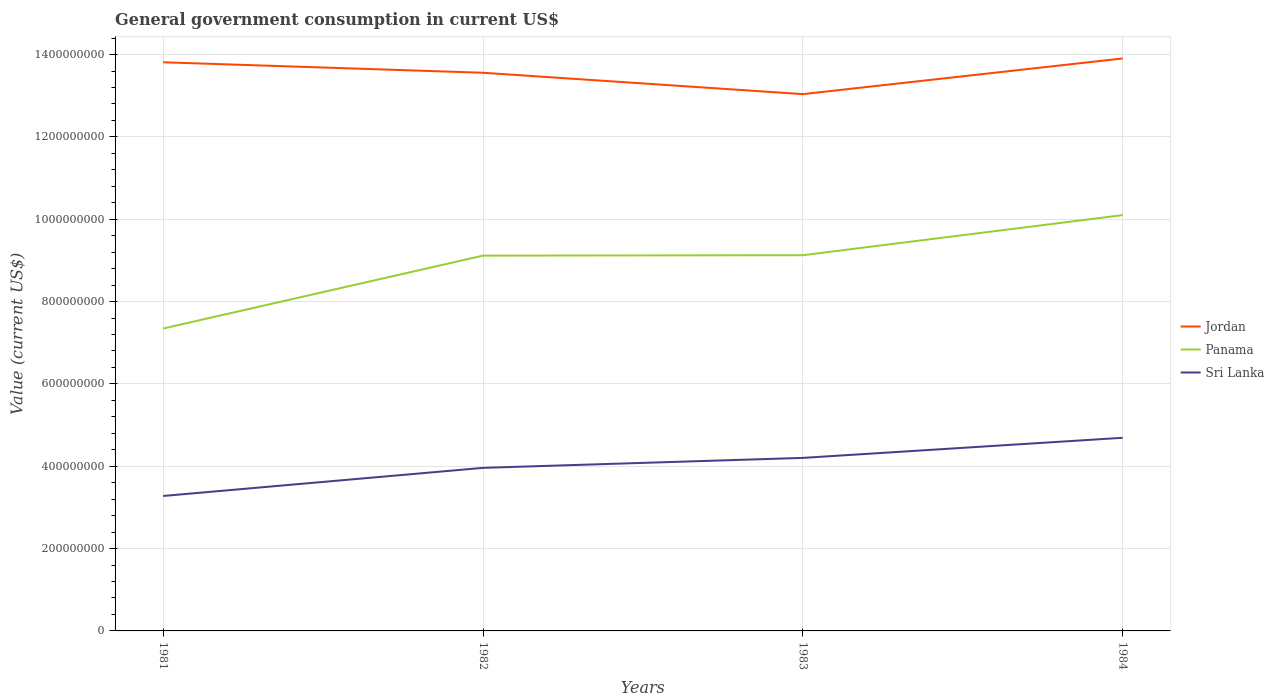How many different coloured lines are there?
Give a very brief answer. 3. Is the number of lines equal to the number of legend labels?
Ensure brevity in your answer.  Yes. Across all years, what is the maximum government conusmption in Jordan?
Provide a succinct answer. 1.30e+09. What is the total government conusmption in Panama in the graph?
Make the answer very short. -9.84e+07. What is the difference between the highest and the second highest government conusmption in Jordan?
Your response must be concise. 8.67e+07. How many lines are there?
Your answer should be very brief. 3. How many years are there in the graph?
Your answer should be compact. 4. What is the difference between two consecutive major ticks on the Y-axis?
Offer a very short reply. 2.00e+08. Does the graph contain any zero values?
Your answer should be compact. No. Where does the legend appear in the graph?
Offer a terse response. Center right. What is the title of the graph?
Make the answer very short. General government consumption in current US$. Does "Montenegro" appear as one of the legend labels in the graph?
Provide a succinct answer. No. What is the label or title of the X-axis?
Offer a terse response. Years. What is the label or title of the Y-axis?
Provide a succinct answer. Value (current US$). What is the Value (current US$) of Jordan in 1981?
Make the answer very short. 1.38e+09. What is the Value (current US$) in Panama in 1981?
Make the answer very short. 7.34e+08. What is the Value (current US$) of Sri Lanka in 1981?
Ensure brevity in your answer.  3.28e+08. What is the Value (current US$) in Jordan in 1982?
Provide a short and direct response. 1.36e+09. What is the Value (current US$) in Panama in 1982?
Your answer should be very brief. 9.12e+08. What is the Value (current US$) of Sri Lanka in 1982?
Offer a very short reply. 3.96e+08. What is the Value (current US$) of Jordan in 1983?
Your answer should be compact. 1.30e+09. What is the Value (current US$) of Panama in 1983?
Keep it short and to the point. 9.13e+08. What is the Value (current US$) of Sri Lanka in 1983?
Keep it short and to the point. 4.20e+08. What is the Value (current US$) in Jordan in 1984?
Offer a terse response. 1.39e+09. What is the Value (current US$) in Panama in 1984?
Provide a short and direct response. 1.01e+09. What is the Value (current US$) of Sri Lanka in 1984?
Your answer should be very brief. 4.69e+08. Across all years, what is the maximum Value (current US$) in Jordan?
Ensure brevity in your answer.  1.39e+09. Across all years, what is the maximum Value (current US$) in Panama?
Provide a short and direct response. 1.01e+09. Across all years, what is the maximum Value (current US$) in Sri Lanka?
Make the answer very short. 4.69e+08. Across all years, what is the minimum Value (current US$) of Jordan?
Give a very brief answer. 1.30e+09. Across all years, what is the minimum Value (current US$) in Panama?
Keep it short and to the point. 7.34e+08. Across all years, what is the minimum Value (current US$) of Sri Lanka?
Your response must be concise. 3.28e+08. What is the total Value (current US$) of Jordan in the graph?
Keep it short and to the point. 5.43e+09. What is the total Value (current US$) in Panama in the graph?
Offer a very short reply. 3.57e+09. What is the total Value (current US$) in Sri Lanka in the graph?
Your answer should be compact. 1.61e+09. What is the difference between the Value (current US$) of Jordan in 1981 and that in 1982?
Offer a terse response. 2.54e+07. What is the difference between the Value (current US$) of Panama in 1981 and that in 1982?
Keep it short and to the point. -1.77e+08. What is the difference between the Value (current US$) of Sri Lanka in 1981 and that in 1982?
Your answer should be compact. -6.83e+07. What is the difference between the Value (current US$) in Jordan in 1981 and that in 1983?
Give a very brief answer. 7.74e+07. What is the difference between the Value (current US$) in Panama in 1981 and that in 1983?
Your answer should be compact. -1.78e+08. What is the difference between the Value (current US$) in Sri Lanka in 1981 and that in 1983?
Your answer should be very brief. -9.25e+07. What is the difference between the Value (current US$) of Jordan in 1981 and that in 1984?
Offer a terse response. -9.29e+06. What is the difference between the Value (current US$) of Panama in 1981 and that in 1984?
Provide a succinct answer. -2.76e+08. What is the difference between the Value (current US$) of Sri Lanka in 1981 and that in 1984?
Your answer should be very brief. -1.41e+08. What is the difference between the Value (current US$) of Jordan in 1982 and that in 1983?
Your response must be concise. 5.19e+07. What is the difference between the Value (current US$) of Sri Lanka in 1982 and that in 1983?
Offer a very short reply. -2.42e+07. What is the difference between the Value (current US$) of Jordan in 1982 and that in 1984?
Your answer should be very brief. -3.47e+07. What is the difference between the Value (current US$) in Panama in 1982 and that in 1984?
Give a very brief answer. -9.84e+07. What is the difference between the Value (current US$) of Sri Lanka in 1982 and that in 1984?
Provide a short and direct response. -7.31e+07. What is the difference between the Value (current US$) of Jordan in 1983 and that in 1984?
Your answer should be very brief. -8.67e+07. What is the difference between the Value (current US$) of Panama in 1983 and that in 1984?
Offer a very short reply. -9.74e+07. What is the difference between the Value (current US$) in Sri Lanka in 1983 and that in 1984?
Your answer should be very brief. -4.89e+07. What is the difference between the Value (current US$) in Jordan in 1981 and the Value (current US$) in Panama in 1982?
Ensure brevity in your answer.  4.70e+08. What is the difference between the Value (current US$) of Jordan in 1981 and the Value (current US$) of Sri Lanka in 1982?
Give a very brief answer. 9.85e+08. What is the difference between the Value (current US$) of Panama in 1981 and the Value (current US$) of Sri Lanka in 1982?
Make the answer very short. 3.38e+08. What is the difference between the Value (current US$) of Jordan in 1981 and the Value (current US$) of Panama in 1983?
Your answer should be compact. 4.69e+08. What is the difference between the Value (current US$) in Jordan in 1981 and the Value (current US$) in Sri Lanka in 1983?
Offer a very short reply. 9.61e+08. What is the difference between the Value (current US$) of Panama in 1981 and the Value (current US$) of Sri Lanka in 1983?
Make the answer very short. 3.14e+08. What is the difference between the Value (current US$) in Jordan in 1981 and the Value (current US$) in Panama in 1984?
Your response must be concise. 3.71e+08. What is the difference between the Value (current US$) of Jordan in 1981 and the Value (current US$) of Sri Lanka in 1984?
Ensure brevity in your answer.  9.12e+08. What is the difference between the Value (current US$) of Panama in 1981 and the Value (current US$) of Sri Lanka in 1984?
Give a very brief answer. 2.65e+08. What is the difference between the Value (current US$) in Jordan in 1982 and the Value (current US$) in Panama in 1983?
Ensure brevity in your answer.  4.43e+08. What is the difference between the Value (current US$) in Jordan in 1982 and the Value (current US$) in Sri Lanka in 1983?
Provide a short and direct response. 9.36e+08. What is the difference between the Value (current US$) in Panama in 1982 and the Value (current US$) in Sri Lanka in 1983?
Give a very brief answer. 4.91e+08. What is the difference between the Value (current US$) in Jordan in 1982 and the Value (current US$) in Panama in 1984?
Your answer should be compact. 3.46e+08. What is the difference between the Value (current US$) in Jordan in 1982 and the Value (current US$) in Sri Lanka in 1984?
Your response must be concise. 8.87e+08. What is the difference between the Value (current US$) in Panama in 1982 and the Value (current US$) in Sri Lanka in 1984?
Ensure brevity in your answer.  4.42e+08. What is the difference between the Value (current US$) of Jordan in 1983 and the Value (current US$) of Panama in 1984?
Your answer should be compact. 2.94e+08. What is the difference between the Value (current US$) of Jordan in 1983 and the Value (current US$) of Sri Lanka in 1984?
Provide a succinct answer. 8.35e+08. What is the difference between the Value (current US$) of Panama in 1983 and the Value (current US$) of Sri Lanka in 1984?
Your answer should be compact. 4.43e+08. What is the average Value (current US$) of Jordan per year?
Give a very brief answer. 1.36e+09. What is the average Value (current US$) of Panama per year?
Your answer should be compact. 8.92e+08. What is the average Value (current US$) of Sri Lanka per year?
Provide a succinct answer. 4.03e+08. In the year 1981, what is the difference between the Value (current US$) in Jordan and Value (current US$) in Panama?
Your answer should be very brief. 6.47e+08. In the year 1981, what is the difference between the Value (current US$) of Jordan and Value (current US$) of Sri Lanka?
Keep it short and to the point. 1.05e+09. In the year 1981, what is the difference between the Value (current US$) in Panama and Value (current US$) in Sri Lanka?
Ensure brevity in your answer.  4.07e+08. In the year 1982, what is the difference between the Value (current US$) of Jordan and Value (current US$) of Panama?
Ensure brevity in your answer.  4.44e+08. In the year 1982, what is the difference between the Value (current US$) of Jordan and Value (current US$) of Sri Lanka?
Offer a very short reply. 9.60e+08. In the year 1982, what is the difference between the Value (current US$) of Panama and Value (current US$) of Sri Lanka?
Your answer should be compact. 5.16e+08. In the year 1983, what is the difference between the Value (current US$) in Jordan and Value (current US$) in Panama?
Offer a very short reply. 3.91e+08. In the year 1983, what is the difference between the Value (current US$) in Jordan and Value (current US$) in Sri Lanka?
Your answer should be very brief. 8.84e+08. In the year 1983, what is the difference between the Value (current US$) in Panama and Value (current US$) in Sri Lanka?
Provide a short and direct response. 4.92e+08. In the year 1984, what is the difference between the Value (current US$) of Jordan and Value (current US$) of Panama?
Give a very brief answer. 3.81e+08. In the year 1984, what is the difference between the Value (current US$) of Jordan and Value (current US$) of Sri Lanka?
Offer a very short reply. 9.21e+08. In the year 1984, what is the difference between the Value (current US$) of Panama and Value (current US$) of Sri Lanka?
Offer a very short reply. 5.41e+08. What is the ratio of the Value (current US$) in Jordan in 1981 to that in 1982?
Offer a terse response. 1.02. What is the ratio of the Value (current US$) in Panama in 1981 to that in 1982?
Your answer should be compact. 0.81. What is the ratio of the Value (current US$) in Sri Lanka in 1981 to that in 1982?
Make the answer very short. 0.83. What is the ratio of the Value (current US$) in Jordan in 1981 to that in 1983?
Make the answer very short. 1.06. What is the ratio of the Value (current US$) of Panama in 1981 to that in 1983?
Your answer should be very brief. 0.8. What is the ratio of the Value (current US$) of Sri Lanka in 1981 to that in 1983?
Offer a very short reply. 0.78. What is the ratio of the Value (current US$) in Jordan in 1981 to that in 1984?
Your answer should be very brief. 0.99. What is the ratio of the Value (current US$) in Panama in 1981 to that in 1984?
Give a very brief answer. 0.73. What is the ratio of the Value (current US$) of Sri Lanka in 1981 to that in 1984?
Your answer should be very brief. 0.7. What is the ratio of the Value (current US$) in Jordan in 1982 to that in 1983?
Your answer should be very brief. 1.04. What is the ratio of the Value (current US$) of Panama in 1982 to that in 1983?
Your answer should be compact. 1. What is the ratio of the Value (current US$) in Sri Lanka in 1982 to that in 1983?
Make the answer very short. 0.94. What is the ratio of the Value (current US$) of Jordan in 1982 to that in 1984?
Your response must be concise. 0.97. What is the ratio of the Value (current US$) of Panama in 1982 to that in 1984?
Your answer should be compact. 0.9. What is the ratio of the Value (current US$) of Sri Lanka in 1982 to that in 1984?
Your answer should be compact. 0.84. What is the ratio of the Value (current US$) of Jordan in 1983 to that in 1984?
Offer a very short reply. 0.94. What is the ratio of the Value (current US$) of Panama in 1983 to that in 1984?
Ensure brevity in your answer.  0.9. What is the ratio of the Value (current US$) of Sri Lanka in 1983 to that in 1984?
Offer a terse response. 0.9. What is the difference between the highest and the second highest Value (current US$) in Jordan?
Provide a succinct answer. 9.29e+06. What is the difference between the highest and the second highest Value (current US$) of Panama?
Your answer should be compact. 9.74e+07. What is the difference between the highest and the second highest Value (current US$) of Sri Lanka?
Offer a very short reply. 4.89e+07. What is the difference between the highest and the lowest Value (current US$) in Jordan?
Your answer should be compact. 8.67e+07. What is the difference between the highest and the lowest Value (current US$) of Panama?
Offer a terse response. 2.76e+08. What is the difference between the highest and the lowest Value (current US$) in Sri Lanka?
Offer a terse response. 1.41e+08. 